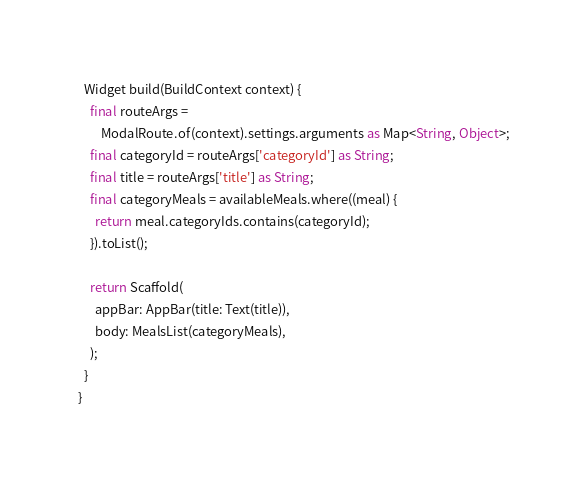<code> <loc_0><loc_0><loc_500><loc_500><_Dart_>  Widget build(BuildContext context) {
    final routeArgs =
        ModalRoute.of(context).settings.arguments as Map<String, Object>;
    final categoryId = routeArgs['categoryId'] as String;
    final title = routeArgs['title'] as String;
    final categoryMeals = availableMeals.where((meal) {
      return meal.categoryIds.contains(categoryId);
    }).toList();

    return Scaffold(
      appBar: AppBar(title: Text(title)),
      body: MealsList(categoryMeals),
    );
  }
}
</code> 